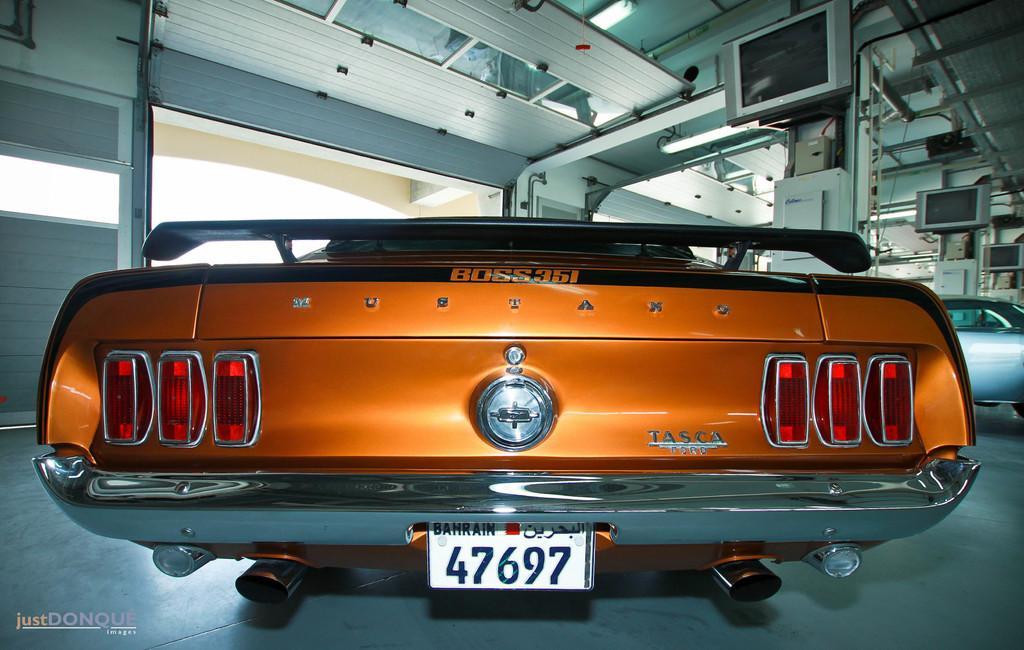Describe this image in one or two sentences. In this image we can see the cars. Beside the cars we can see the pillars. There are televisions attached to the pillars. On the left side, we can see a wall. At the top we can see the roof and lights. 